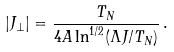<formula> <loc_0><loc_0><loc_500><loc_500>| J _ { \perp } | = \frac { T _ { N } } { 4 A \ln ^ { 1 / 2 } ( \Lambda J / T _ { N } ) } \, .</formula> 